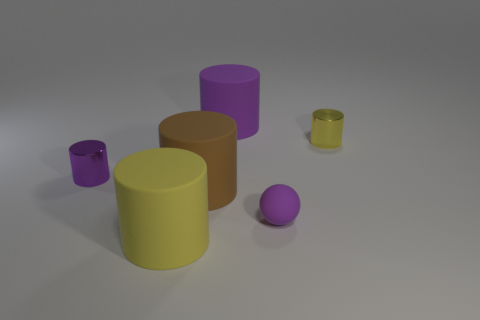Could you estimate how many objects are there in the image, and are they all the same shape? There are five objects in the image. They vary in shape; there are two cylinders and three spheres. 